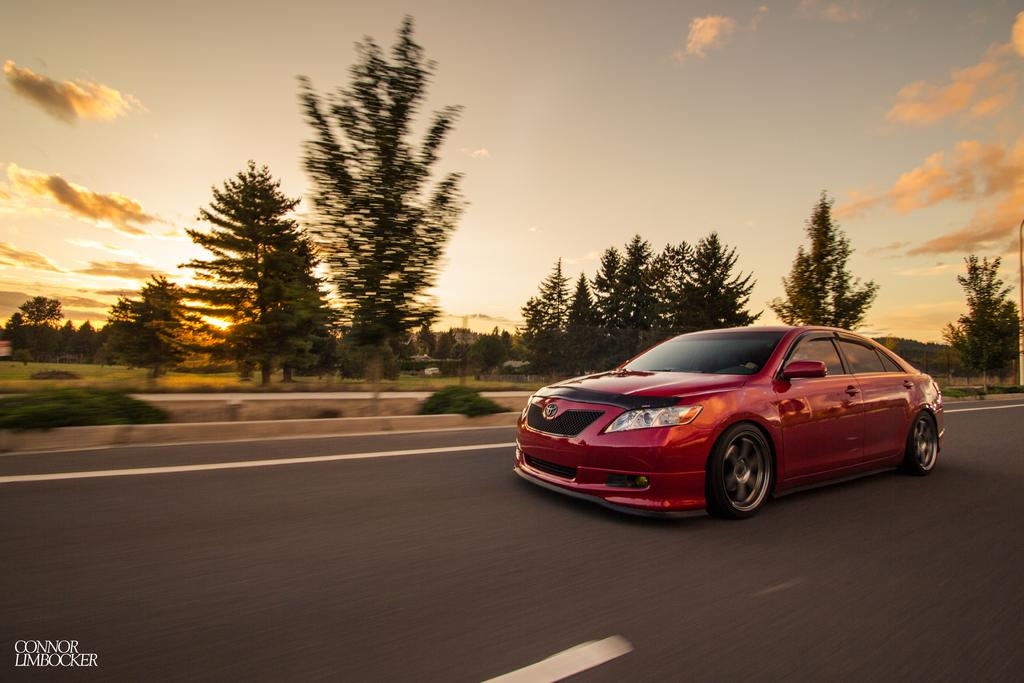What color is the car in the image? The car in the image is red. What is the car doing in the image? The car is moving on the road. What can be seen in the background of the image? There are trees visible in the image. How many times has the car been stitched in the image? The car has not been stitched in the image; it is a real car. Can you tell me how many kicks the car has received in the image? The car has not been kicked in the image; it is moving on the road. 